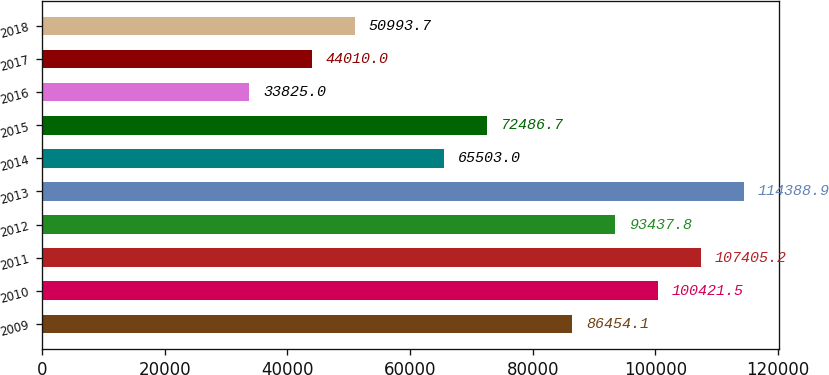Convert chart to OTSL. <chart><loc_0><loc_0><loc_500><loc_500><bar_chart><fcel>2009<fcel>2010<fcel>2011<fcel>2012<fcel>2013<fcel>2014<fcel>2015<fcel>2016<fcel>2017<fcel>2018<nl><fcel>86454.1<fcel>100422<fcel>107405<fcel>93437.8<fcel>114389<fcel>65503<fcel>72486.7<fcel>33825<fcel>44010<fcel>50993.7<nl></chart> 